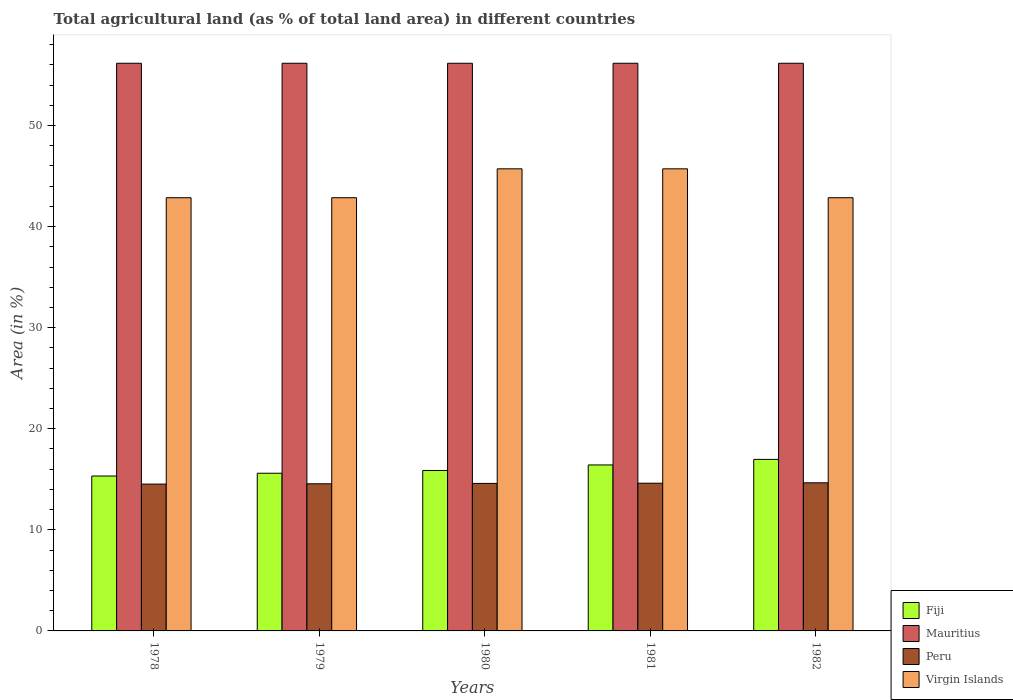How many different coloured bars are there?
Your answer should be very brief. 4. How many groups of bars are there?
Make the answer very short. 5. How many bars are there on the 3rd tick from the left?
Ensure brevity in your answer.  4. What is the label of the 1st group of bars from the left?
Give a very brief answer. 1978. In how many cases, is the number of bars for a given year not equal to the number of legend labels?
Provide a short and direct response. 0. What is the percentage of agricultural land in Fiji in 1978?
Your response must be concise. 15.33. Across all years, what is the maximum percentage of agricultural land in Mauritius?
Your answer should be compact. 56.16. Across all years, what is the minimum percentage of agricultural land in Fiji?
Give a very brief answer. 15.33. In which year was the percentage of agricultural land in Peru maximum?
Your response must be concise. 1982. In which year was the percentage of agricultural land in Fiji minimum?
Offer a very short reply. 1978. What is the total percentage of agricultural land in Virgin Islands in the graph?
Ensure brevity in your answer.  220. What is the difference between the percentage of agricultural land in Mauritius in 1978 and that in 1980?
Keep it short and to the point. 0. What is the difference between the percentage of agricultural land in Mauritius in 1982 and the percentage of agricultural land in Fiji in 1980?
Offer a terse response. 40.28. What is the average percentage of agricultural land in Peru per year?
Keep it short and to the point. 14.59. In the year 1981, what is the difference between the percentage of agricultural land in Mauritius and percentage of agricultural land in Peru?
Your answer should be very brief. 41.55. In how many years, is the percentage of agricultural land in Mauritius greater than 4 %?
Your response must be concise. 5. Is the difference between the percentage of agricultural land in Mauritius in 1979 and 1982 greater than the difference between the percentage of agricultural land in Peru in 1979 and 1982?
Your response must be concise. Yes. What is the difference between the highest and the second highest percentage of agricultural land in Peru?
Your response must be concise. 0.04. What is the difference between the highest and the lowest percentage of agricultural land in Mauritius?
Make the answer very short. 0. In how many years, is the percentage of agricultural land in Mauritius greater than the average percentage of agricultural land in Mauritius taken over all years?
Give a very brief answer. 0. Is the sum of the percentage of agricultural land in Mauritius in 1978 and 1980 greater than the maximum percentage of agricultural land in Virgin Islands across all years?
Make the answer very short. Yes. Is it the case that in every year, the sum of the percentage of agricultural land in Mauritius and percentage of agricultural land in Fiji is greater than the sum of percentage of agricultural land in Peru and percentage of agricultural land in Virgin Islands?
Provide a short and direct response. Yes. What does the 4th bar from the left in 1979 represents?
Give a very brief answer. Virgin Islands. What does the 4th bar from the right in 1978 represents?
Your answer should be very brief. Fiji. How many bars are there?
Your answer should be very brief. 20. What is the difference between two consecutive major ticks on the Y-axis?
Ensure brevity in your answer.  10. Are the values on the major ticks of Y-axis written in scientific E-notation?
Your answer should be very brief. No. Does the graph contain grids?
Make the answer very short. No. How are the legend labels stacked?
Make the answer very short. Vertical. What is the title of the graph?
Provide a succinct answer. Total agricultural land (as % of total land area) in different countries. What is the label or title of the Y-axis?
Give a very brief answer. Area (in %). What is the Area (in %) of Fiji in 1978?
Provide a short and direct response. 15.33. What is the Area (in %) of Mauritius in 1978?
Offer a terse response. 56.16. What is the Area (in %) in Peru in 1978?
Give a very brief answer. 14.53. What is the Area (in %) of Virgin Islands in 1978?
Offer a terse response. 42.86. What is the Area (in %) of Fiji in 1979?
Your answer should be very brief. 15.6. What is the Area (in %) in Mauritius in 1979?
Your response must be concise. 56.16. What is the Area (in %) of Peru in 1979?
Your response must be concise. 14.55. What is the Area (in %) in Virgin Islands in 1979?
Your answer should be compact. 42.86. What is the Area (in %) in Fiji in 1980?
Provide a succinct answer. 15.87. What is the Area (in %) in Mauritius in 1980?
Offer a very short reply. 56.16. What is the Area (in %) of Peru in 1980?
Keep it short and to the point. 14.59. What is the Area (in %) of Virgin Islands in 1980?
Keep it short and to the point. 45.71. What is the Area (in %) in Fiji in 1981?
Your response must be concise. 16.42. What is the Area (in %) of Mauritius in 1981?
Offer a terse response. 56.16. What is the Area (in %) of Peru in 1981?
Offer a very short reply. 14.61. What is the Area (in %) of Virgin Islands in 1981?
Make the answer very short. 45.71. What is the Area (in %) of Fiji in 1982?
Make the answer very short. 16.97. What is the Area (in %) in Mauritius in 1982?
Offer a very short reply. 56.16. What is the Area (in %) in Peru in 1982?
Your response must be concise. 14.65. What is the Area (in %) in Virgin Islands in 1982?
Ensure brevity in your answer.  42.86. Across all years, what is the maximum Area (in %) of Fiji?
Offer a terse response. 16.97. Across all years, what is the maximum Area (in %) in Mauritius?
Your answer should be compact. 56.16. Across all years, what is the maximum Area (in %) of Peru?
Make the answer very short. 14.65. Across all years, what is the maximum Area (in %) in Virgin Islands?
Your response must be concise. 45.71. Across all years, what is the minimum Area (in %) of Fiji?
Offer a terse response. 15.33. Across all years, what is the minimum Area (in %) in Mauritius?
Provide a succinct answer. 56.16. Across all years, what is the minimum Area (in %) in Peru?
Make the answer very short. 14.53. Across all years, what is the minimum Area (in %) of Virgin Islands?
Your response must be concise. 42.86. What is the total Area (in %) of Fiji in the graph?
Offer a terse response. 80.19. What is the total Area (in %) in Mauritius in the graph?
Offer a terse response. 280.79. What is the total Area (in %) in Peru in the graph?
Your answer should be compact. 72.94. What is the total Area (in %) in Virgin Islands in the graph?
Offer a very short reply. 220. What is the difference between the Area (in %) of Fiji in 1978 and that in 1979?
Offer a terse response. -0.27. What is the difference between the Area (in %) of Peru in 1978 and that in 1979?
Ensure brevity in your answer.  -0.03. What is the difference between the Area (in %) in Fiji in 1978 and that in 1980?
Your answer should be very brief. -0.55. What is the difference between the Area (in %) of Mauritius in 1978 and that in 1980?
Offer a very short reply. 0. What is the difference between the Area (in %) in Peru in 1978 and that in 1980?
Ensure brevity in your answer.  -0.07. What is the difference between the Area (in %) of Virgin Islands in 1978 and that in 1980?
Provide a short and direct response. -2.86. What is the difference between the Area (in %) of Fiji in 1978 and that in 1981?
Ensure brevity in your answer.  -1.09. What is the difference between the Area (in %) in Mauritius in 1978 and that in 1981?
Your answer should be very brief. 0. What is the difference between the Area (in %) of Peru in 1978 and that in 1981?
Offer a terse response. -0.09. What is the difference between the Area (in %) of Virgin Islands in 1978 and that in 1981?
Keep it short and to the point. -2.86. What is the difference between the Area (in %) in Fiji in 1978 and that in 1982?
Offer a terse response. -1.64. What is the difference between the Area (in %) of Peru in 1978 and that in 1982?
Provide a short and direct response. -0.12. What is the difference between the Area (in %) of Fiji in 1979 and that in 1980?
Give a very brief answer. -0.27. What is the difference between the Area (in %) in Peru in 1979 and that in 1980?
Offer a terse response. -0.04. What is the difference between the Area (in %) in Virgin Islands in 1979 and that in 1980?
Give a very brief answer. -2.86. What is the difference between the Area (in %) in Fiji in 1979 and that in 1981?
Provide a succinct answer. -0.82. What is the difference between the Area (in %) of Mauritius in 1979 and that in 1981?
Your answer should be very brief. 0. What is the difference between the Area (in %) of Peru in 1979 and that in 1981?
Your answer should be compact. -0.06. What is the difference between the Area (in %) in Virgin Islands in 1979 and that in 1981?
Provide a succinct answer. -2.86. What is the difference between the Area (in %) in Fiji in 1979 and that in 1982?
Provide a succinct answer. -1.37. What is the difference between the Area (in %) of Peru in 1979 and that in 1982?
Provide a short and direct response. -0.1. What is the difference between the Area (in %) in Virgin Islands in 1979 and that in 1982?
Your answer should be compact. 0. What is the difference between the Area (in %) in Fiji in 1980 and that in 1981?
Give a very brief answer. -0.55. What is the difference between the Area (in %) of Mauritius in 1980 and that in 1981?
Provide a succinct answer. 0. What is the difference between the Area (in %) in Peru in 1980 and that in 1981?
Your response must be concise. -0.02. What is the difference between the Area (in %) in Fiji in 1980 and that in 1982?
Your response must be concise. -1.09. What is the difference between the Area (in %) in Mauritius in 1980 and that in 1982?
Provide a short and direct response. 0. What is the difference between the Area (in %) in Peru in 1980 and that in 1982?
Give a very brief answer. -0.06. What is the difference between the Area (in %) in Virgin Islands in 1980 and that in 1982?
Your answer should be compact. 2.86. What is the difference between the Area (in %) of Fiji in 1981 and that in 1982?
Provide a short and direct response. -0.55. What is the difference between the Area (in %) in Peru in 1981 and that in 1982?
Give a very brief answer. -0.04. What is the difference between the Area (in %) of Virgin Islands in 1981 and that in 1982?
Offer a terse response. 2.86. What is the difference between the Area (in %) of Fiji in 1978 and the Area (in %) of Mauritius in 1979?
Keep it short and to the point. -40.83. What is the difference between the Area (in %) of Fiji in 1978 and the Area (in %) of Peru in 1979?
Provide a succinct answer. 0.77. What is the difference between the Area (in %) in Fiji in 1978 and the Area (in %) in Virgin Islands in 1979?
Make the answer very short. -27.53. What is the difference between the Area (in %) of Mauritius in 1978 and the Area (in %) of Peru in 1979?
Provide a short and direct response. 41.6. What is the difference between the Area (in %) of Mauritius in 1978 and the Area (in %) of Virgin Islands in 1979?
Give a very brief answer. 13.3. What is the difference between the Area (in %) in Peru in 1978 and the Area (in %) in Virgin Islands in 1979?
Ensure brevity in your answer.  -28.33. What is the difference between the Area (in %) in Fiji in 1978 and the Area (in %) in Mauritius in 1980?
Make the answer very short. -40.83. What is the difference between the Area (in %) of Fiji in 1978 and the Area (in %) of Peru in 1980?
Ensure brevity in your answer.  0.73. What is the difference between the Area (in %) of Fiji in 1978 and the Area (in %) of Virgin Islands in 1980?
Offer a terse response. -30.39. What is the difference between the Area (in %) of Mauritius in 1978 and the Area (in %) of Peru in 1980?
Make the answer very short. 41.56. What is the difference between the Area (in %) of Mauritius in 1978 and the Area (in %) of Virgin Islands in 1980?
Provide a short and direct response. 10.44. What is the difference between the Area (in %) in Peru in 1978 and the Area (in %) in Virgin Islands in 1980?
Provide a succinct answer. -31.19. What is the difference between the Area (in %) in Fiji in 1978 and the Area (in %) in Mauritius in 1981?
Give a very brief answer. -40.83. What is the difference between the Area (in %) in Fiji in 1978 and the Area (in %) in Peru in 1981?
Ensure brevity in your answer.  0.71. What is the difference between the Area (in %) of Fiji in 1978 and the Area (in %) of Virgin Islands in 1981?
Offer a terse response. -30.39. What is the difference between the Area (in %) of Mauritius in 1978 and the Area (in %) of Peru in 1981?
Give a very brief answer. 41.55. What is the difference between the Area (in %) of Mauritius in 1978 and the Area (in %) of Virgin Islands in 1981?
Your answer should be compact. 10.44. What is the difference between the Area (in %) of Peru in 1978 and the Area (in %) of Virgin Islands in 1981?
Keep it short and to the point. -31.19. What is the difference between the Area (in %) of Fiji in 1978 and the Area (in %) of Mauritius in 1982?
Keep it short and to the point. -40.83. What is the difference between the Area (in %) in Fiji in 1978 and the Area (in %) in Peru in 1982?
Offer a very short reply. 0.67. What is the difference between the Area (in %) in Fiji in 1978 and the Area (in %) in Virgin Islands in 1982?
Keep it short and to the point. -27.53. What is the difference between the Area (in %) of Mauritius in 1978 and the Area (in %) of Peru in 1982?
Offer a terse response. 41.51. What is the difference between the Area (in %) of Mauritius in 1978 and the Area (in %) of Virgin Islands in 1982?
Give a very brief answer. 13.3. What is the difference between the Area (in %) in Peru in 1978 and the Area (in %) in Virgin Islands in 1982?
Ensure brevity in your answer.  -28.33. What is the difference between the Area (in %) in Fiji in 1979 and the Area (in %) in Mauritius in 1980?
Offer a very short reply. -40.56. What is the difference between the Area (in %) in Fiji in 1979 and the Area (in %) in Peru in 1980?
Provide a succinct answer. 1.01. What is the difference between the Area (in %) of Fiji in 1979 and the Area (in %) of Virgin Islands in 1980?
Provide a short and direct response. -30.11. What is the difference between the Area (in %) in Mauritius in 1979 and the Area (in %) in Peru in 1980?
Offer a very short reply. 41.56. What is the difference between the Area (in %) of Mauritius in 1979 and the Area (in %) of Virgin Islands in 1980?
Make the answer very short. 10.44. What is the difference between the Area (in %) in Peru in 1979 and the Area (in %) in Virgin Islands in 1980?
Give a very brief answer. -31.16. What is the difference between the Area (in %) of Fiji in 1979 and the Area (in %) of Mauritius in 1981?
Offer a terse response. -40.56. What is the difference between the Area (in %) of Fiji in 1979 and the Area (in %) of Virgin Islands in 1981?
Make the answer very short. -30.11. What is the difference between the Area (in %) in Mauritius in 1979 and the Area (in %) in Peru in 1981?
Your answer should be very brief. 41.55. What is the difference between the Area (in %) in Mauritius in 1979 and the Area (in %) in Virgin Islands in 1981?
Keep it short and to the point. 10.44. What is the difference between the Area (in %) of Peru in 1979 and the Area (in %) of Virgin Islands in 1981?
Make the answer very short. -31.16. What is the difference between the Area (in %) of Fiji in 1979 and the Area (in %) of Mauritius in 1982?
Your answer should be very brief. -40.56. What is the difference between the Area (in %) of Fiji in 1979 and the Area (in %) of Peru in 1982?
Give a very brief answer. 0.95. What is the difference between the Area (in %) in Fiji in 1979 and the Area (in %) in Virgin Islands in 1982?
Offer a terse response. -27.26. What is the difference between the Area (in %) of Mauritius in 1979 and the Area (in %) of Peru in 1982?
Your answer should be very brief. 41.51. What is the difference between the Area (in %) of Mauritius in 1979 and the Area (in %) of Virgin Islands in 1982?
Offer a terse response. 13.3. What is the difference between the Area (in %) of Peru in 1979 and the Area (in %) of Virgin Islands in 1982?
Provide a short and direct response. -28.3. What is the difference between the Area (in %) in Fiji in 1980 and the Area (in %) in Mauritius in 1981?
Your answer should be very brief. -40.28. What is the difference between the Area (in %) in Fiji in 1980 and the Area (in %) in Peru in 1981?
Your answer should be very brief. 1.26. What is the difference between the Area (in %) in Fiji in 1980 and the Area (in %) in Virgin Islands in 1981?
Your answer should be very brief. -29.84. What is the difference between the Area (in %) in Mauritius in 1980 and the Area (in %) in Peru in 1981?
Make the answer very short. 41.55. What is the difference between the Area (in %) in Mauritius in 1980 and the Area (in %) in Virgin Islands in 1981?
Make the answer very short. 10.44. What is the difference between the Area (in %) in Peru in 1980 and the Area (in %) in Virgin Islands in 1981?
Provide a succinct answer. -31.12. What is the difference between the Area (in %) in Fiji in 1980 and the Area (in %) in Mauritius in 1982?
Offer a very short reply. -40.28. What is the difference between the Area (in %) in Fiji in 1980 and the Area (in %) in Peru in 1982?
Ensure brevity in your answer.  1.22. What is the difference between the Area (in %) of Fiji in 1980 and the Area (in %) of Virgin Islands in 1982?
Your response must be concise. -26.98. What is the difference between the Area (in %) in Mauritius in 1980 and the Area (in %) in Peru in 1982?
Offer a very short reply. 41.51. What is the difference between the Area (in %) of Mauritius in 1980 and the Area (in %) of Virgin Islands in 1982?
Make the answer very short. 13.3. What is the difference between the Area (in %) in Peru in 1980 and the Area (in %) in Virgin Islands in 1982?
Offer a terse response. -28.26. What is the difference between the Area (in %) of Fiji in 1981 and the Area (in %) of Mauritius in 1982?
Provide a short and direct response. -39.74. What is the difference between the Area (in %) of Fiji in 1981 and the Area (in %) of Peru in 1982?
Your answer should be very brief. 1.77. What is the difference between the Area (in %) in Fiji in 1981 and the Area (in %) in Virgin Islands in 1982?
Give a very brief answer. -26.44. What is the difference between the Area (in %) of Mauritius in 1981 and the Area (in %) of Peru in 1982?
Ensure brevity in your answer.  41.51. What is the difference between the Area (in %) of Mauritius in 1981 and the Area (in %) of Virgin Islands in 1982?
Offer a terse response. 13.3. What is the difference between the Area (in %) of Peru in 1981 and the Area (in %) of Virgin Islands in 1982?
Provide a succinct answer. -28.24. What is the average Area (in %) of Fiji per year?
Give a very brief answer. 16.04. What is the average Area (in %) in Mauritius per year?
Provide a succinct answer. 56.16. What is the average Area (in %) in Peru per year?
Provide a short and direct response. 14.59. In the year 1978, what is the difference between the Area (in %) in Fiji and Area (in %) in Mauritius?
Your response must be concise. -40.83. In the year 1978, what is the difference between the Area (in %) of Fiji and Area (in %) of Peru?
Your answer should be compact. 0.8. In the year 1978, what is the difference between the Area (in %) in Fiji and Area (in %) in Virgin Islands?
Keep it short and to the point. -27.53. In the year 1978, what is the difference between the Area (in %) of Mauritius and Area (in %) of Peru?
Give a very brief answer. 41.63. In the year 1978, what is the difference between the Area (in %) in Mauritius and Area (in %) in Virgin Islands?
Offer a terse response. 13.3. In the year 1978, what is the difference between the Area (in %) of Peru and Area (in %) of Virgin Islands?
Ensure brevity in your answer.  -28.33. In the year 1979, what is the difference between the Area (in %) in Fiji and Area (in %) in Mauritius?
Ensure brevity in your answer.  -40.56. In the year 1979, what is the difference between the Area (in %) in Fiji and Area (in %) in Peru?
Your answer should be compact. 1.04. In the year 1979, what is the difference between the Area (in %) in Fiji and Area (in %) in Virgin Islands?
Make the answer very short. -27.26. In the year 1979, what is the difference between the Area (in %) of Mauritius and Area (in %) of Peru?
Your answer should be very brief. 41.6. In the year 1979, what is the difference between the Area (in %) in Mauritius and Area (in %) in Virgin Islands?
Your answer should be very brief. 13.3. In the year 1979, what is the difference between the Area (in %) of Peru and Area (in %) of Virgin Islands?
Offer a very short reply. -28.3. In the year 1980, what is the difference between the Area (in %) in Fiji and Area (in %) in Mauritius?
Ensure brevity in your answer.  -40.28. In the year 1980, what is the difference between the Area (in %) of Fiji and Area (in %) of Peru?
Ensure brevity in your answer.  1.28. In the year 1980, what is the difference between the Area (in %) of Fiji and Area (in %) of Virgin Islands?
Offer a very short reply. -29.84. In the year 1980, what is the difference between the Area (in %) in Mauritius and Area (in %) in Peru?
Give a very brief answer. 41.56. In the year 1980, what is the difference between the Area (in %) of Mauritius and Area (in %) of Virgin Islands?
Keep it short and to the point. 10.44. In the year 1980, what is the difference between the Area (in %) in Peru and Area (in %) in Virgin Islands?
Offer a terse response. -31.12. In the year 1981, what is the difference between the Area (in %) in Fiji and Area (in %) in Mauritius?
Your response must be concise. -39.74. In the year 1981, what is the difference between the Area (in %) in Fiji and Area (in %) in Peru?
Provide a succinct answer. 1.81. In the year 1981, what is the difference between the Area (in %) of Fiji and Area (in %) of Virgin Islands?
Give a very brief answer. -29.29. In the year 1981, what is the difference between the Area (in %) in Mauritius and Area (in %) in Peru?
Your response must be concise. 41.55. In the year 1981, what is the difference between the Area (in %) of Mauritius and Area (in %) of Virgin Islands?
Provide a succinct answer. 10.44. In the year 1981, what is the difference between the Area (in %) of Peru and Area (in %) of Virgin Islands?
Your answer should be very brief. -31.1. In the year 1982, what is the difference between the Area (in %) in Fiji and Area (in %) in Mauritius?
Your response must be concise. -39.19. In the year 1982, what is the difference between the Area (in %) in Fiji and Area (in %) in Peru?
Your answer should be very brief. 2.32. In the year 1982, what is the difference between the Area (in %) of Fiji and Area (in %) of Virgin Islands?
Your response must be concise. -25.89. In the year 1982, what is the difference between the Area (in %) in Mauritius and Area (in %) in Peru?
Make the answer very short. 41.51. In the year 1982, what is the difference between the Area (in %) in Mauritius and Area (in %) in Virgin Islands?
Give a very brief answer. 13.3. In the year 1982, what is the difference between the Area (in %) in Peru and Area (in %) in Virgin Islands?
Your answer should be very brief. -28.21. What is the ratio of the Area (in %) in Fiji in 1978 to that in 1979?
Make the answer very short. 0.98. What is the ratio of the Area (in %) of Fiji in 1978 to that in 1980?
Make the answer very short. 0.97. What is the ratio of the Area (in %) of Fiji in 1978 to that in 1981?
Provide a short and direct response. 0.93. What is the ratio of the Area (in %) in Virgin Islands in 1978 to that in 1981?
Keep it short and to the point. 0.94. What is the ratio of the Area (in %) of Fiji in 1978 to that in 1982?
Make the answer very short. 0.9. What is the ratio of the Area (in %) of Fiji in 1979 to that in 1980?
Your response must be concise. 0.98. What is the ratio of the Area (in %) of Peru in 1979 to that in 1980?
Give a very brief answer. 1. What is the ratio of the Area (in %) in Mauritius in 1979 to that in 1981?
Offer a terse response. 1. What is the ratio of the Area (in %) in Peru in 1979 to that in 1981?
Give a very brief answer. 1. What is the ratio of the Area (in %) of Fiji in 1979 to that in 1982?
Offer a very short reply. 0.92. What is the ratio of the Area (in %) in Mauritius in 1979 to that in 1982?
Keep it short and to the point. 1. What is the ratio of the Area (in %) in Peru in 1979 to that in 1982?
Your response must be concise. 0.99. What is the ratio of the Area (in %) of Virgin Islands in 1979 to that in 1982?
Make the answer very short. 1. What is the ratio of the Area (in %) in Fiji in 1980 to that in 1981?
Offer a terse response. 0.97. What is the ratio of the Area (in %) in Fiji in 1980 to that in 1982?
Offer a terse response. 0.94. What is the ratio of the Area (in %) in Virgin Islands in 1980 to that in 1982?
Provide a succinct answer. 1.07. What is the ratio of the Area (in %) in Fiji in 1981 to that in 1982?
Your response must be concise. 0.97. What is the ratio of the Area (in %) of Peru in 1981 to that in 1982?
Provide a short and direct response. 1. What is the ratio of the Area (in %) in Virgin Islands in 1981 to that in 1982?
Ensure brevity in your answer.  1.07. What is the difference between the highest and the second highest Area (in %) in Fiji?
Keep it short and to the point. 0.55. What is the difference between the highest and the second highest Area (in %) in Peru?
Make the answer very short. 0.04. What is the difference between the highest and the lowest Area (in %) in Fiji?
Make the answer very short. 1.64. What is the difference between the highest and the lowest Area (in %) in Mauritius?
Provide a short and direct response. 0. What is the difference between the highest and the lowest Area (in %) of Peru?
Your answer should be very brief. 0.12. What is the difference between the highest and the lowest Area (in %) in Virgin Islands?
Offer a terse response. 2.86. 